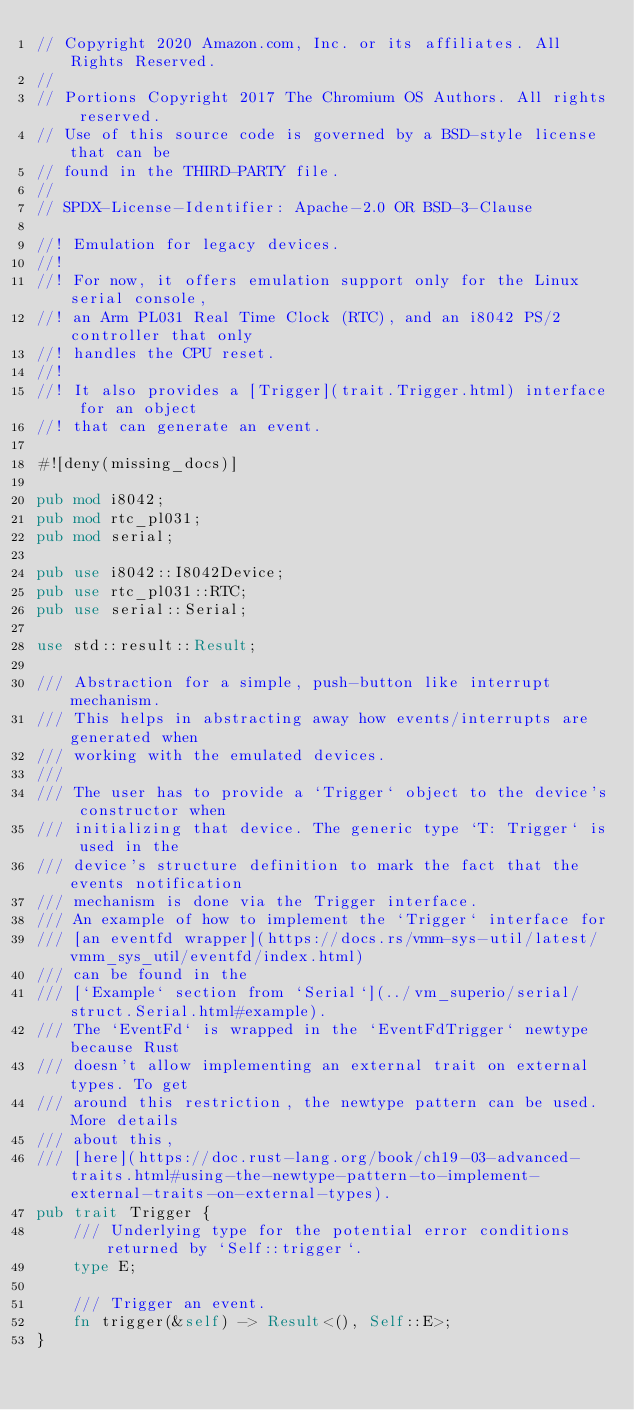Convert code to text. <code><loc_0><loc_0><loc_500><loc_500><_Rust_>// Copyright 2020 Amazon.com, Inc. or its affiliates. All Rights Reserved.
//
// Portions Copyright 2017 The Chromium OS Authors. All rights reserved.
// Use of this source code is governed by a BSD-style license that can be
// found in the THIRD-PARTY file.
//
// SPDX-License-Identifier: Apache-2.0 OR BSD-3-Clause

//! Emulation for legacy devices.
//!
//! For now, it offers emulation support only for the Linux serial console,
//! an Arm PL031 Real Time Clock (RTC), and an i8042 PS/2 controller that only
//! handles the CPU reset.
//!
//! It also provides a [Trigger](trait.Trigger.html) interface for an object
//! that can generate an event.

#![deny(missing_docs)]

pub mod i8042;
pub mod rtc_pl031;
pub mod serial;

pub use i8042::I8042Device;
pub use rtc_pl031::RTC;
pub use serial::Serial;

use std::result::Result;

/// Abstraction for a simple, push-button like interrupt mechanism.
/// This helps in abstracting away how events/interrupts are generated when
/// working with the emulated devices.
///
/// The user has to provide a `Trigger` object to the device's constructor when
/// initializing that device. The generic type `T: Trigger` is used in the
/// device's structure definition to mark the fact that the events notification
/// mechanism is done via the Trigger interface.
/// An example of how to implement the `Trigger` interface for
/// [an eventfd wrapper](https://docs.rs/vmm-sys-util/latest/vmm_sys_util/eventfd/index.html)
/// can be found in the
/// [`Example` section from `Serial`](../vm_superio/serial/struct.Serial.html#example).
/// The `EventFd` is wrapped in the `EventFdTrigger` newtype because Rust
/// doesn't allow implementing an external trait on external types. To get
/// around this restriction, the newtype pattern can be used. More details
/// about this,
/// [here](https://doc.rust-lang.org/book/ch19-03-advanced-traits.html#using-the-newtype-pattern-to-implement-external-traits-on-external-types).
pub trait Trigger {
    /// Underlying type for the potential error conditions returned by `Self::trigger`.
    type E;

    /// Trigger an event.
    fn trigger(&self) -> Result<(), Self::E>;
}
</code> 